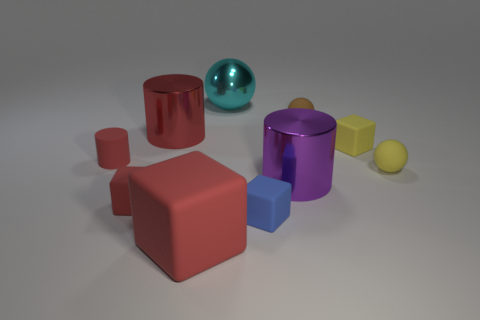Is the shape of the big object that is to the right of the large cyan metallic sphere the same as the rubber object behind the tiny yellow block?
Provide a succinct answer. No. There is a large thing that is both to the left of the large cyan shiny thing and behind the tiny blue rubber cube; what is its shape?
Make the answer very short. Cylinder. There is a red object that is made of the same material as the large cyan object; what is its size?
Keep it short and to the point. Large. Are there fewer green metal cylinders than large purple shiny cylinders?
Ensure brevity in your answer.  Yes. There is a cube on the left side of the big red thing behind the large thing that is in front of the purple thing; what is its material?
Keep it short and to the point. Rubber. Is the small sphere in front of the red rubber cylinder made of the same material as the block that is right of the blue block?
Your answer should be compact. Yes. There is a red rubber thing that is both behind the big red block and in front of the small yellow matte sphere; what is its size?
Offer a terse response. Small. There is a yellow block that is the same size as the blue matte block; what is it made of?
Make the answer very short. Rubber. What number of cyan shiny balls are in front of the yellow object behind the small ball right of the brown matte sphere?
Your answer should be compact. 0. There is a small matte thing that is in front of the small red cube; is its color the same as the object that is in front of the tiny blue object?
Give a very brief answer. No. 